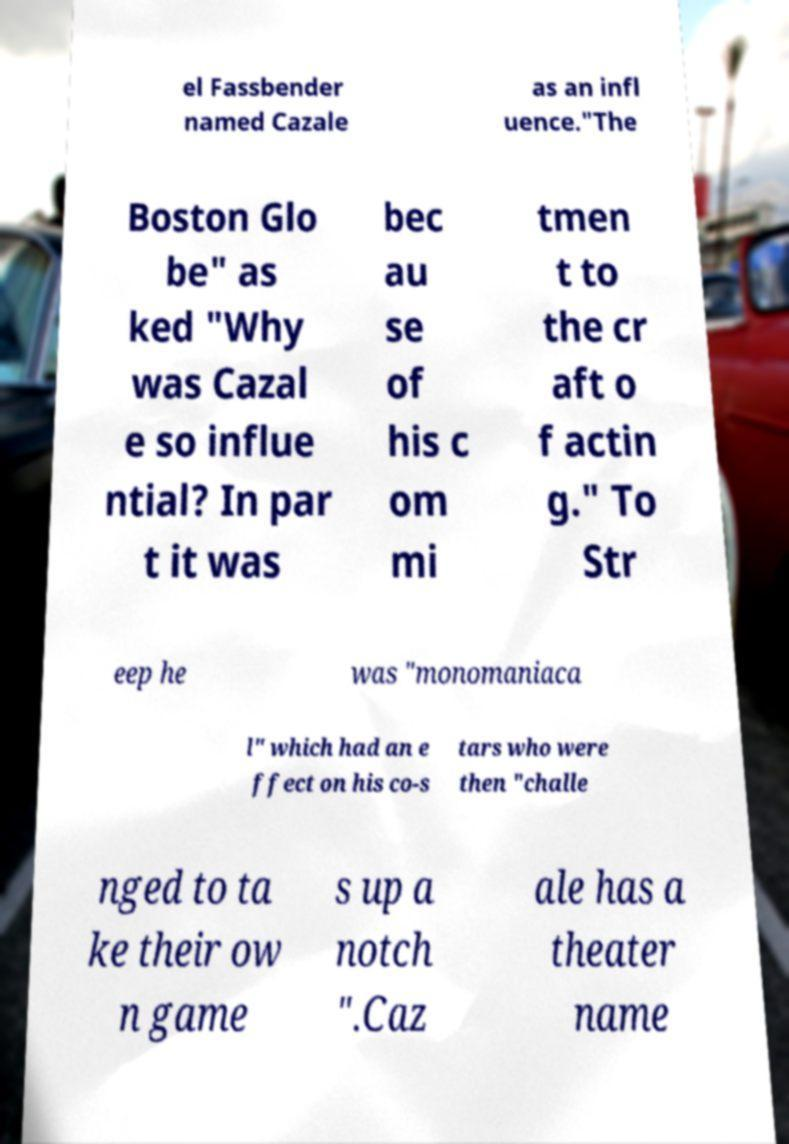There's text embedded in this image that I need extracted. Can you transcribe it verbatim? el Fassbender named Cazale as an infl uence."The Boston Glo be" as ked "Why was Cazal e so influe ntial? In par t it was bec au se of his c om mi tmen t to the cr aft o f actin g." To Str eep he was "monomaniaca l" which had an e ffect on his co-s tars who were then "challe nged to ta ke their ow n game s up a notch ".Caz ale has a theater name 